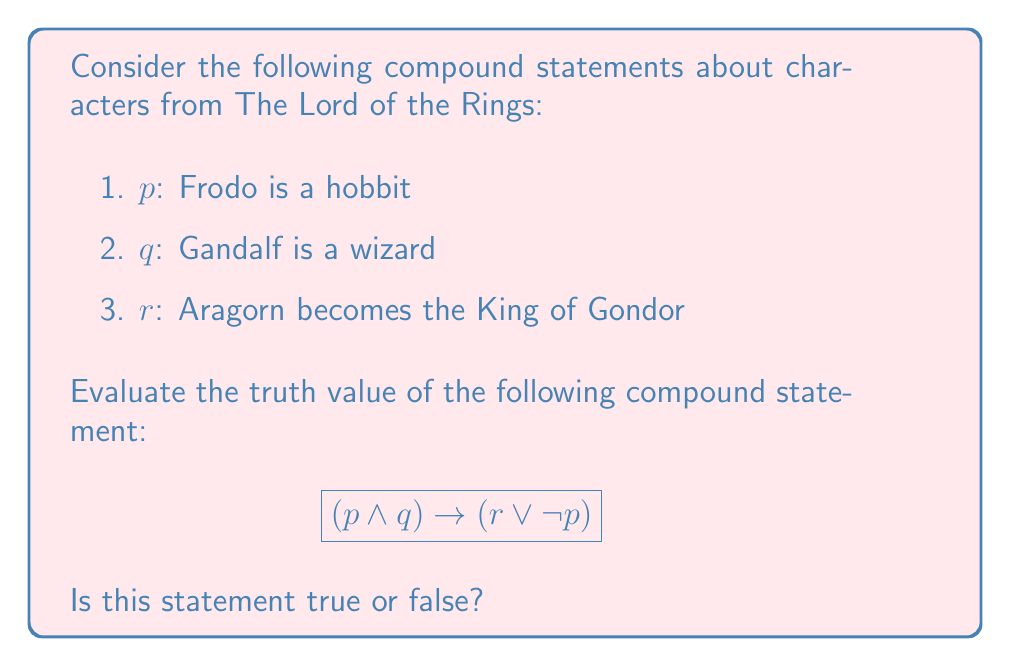What is the answer to this math problem? Let's evaluate this compound statement step-by-step:

1. First, we need to determine the truth values of the individual statements:
   $p$: True (Frodo is indeed a hobbit)
   $q$: True (Gandalf is indeed a wizard)
   $r$: True (Aragorn does become the King of Gondor)

2. Now, let's evaluate the left side of the implication: $(p \land q)$
   $p \land q$ = True $\land$ True = True

3. Next, let's evaluate the right side of the implication: $(r \lor \neg p)$
   $\neg p$ = False (since $p$ is True)
   $r \lor \neg p$ = True $\lor$ False = True

4. Now we have the implication: True $\rightarrow$ True

5. Recall the truth table for implication:
   $$\begin{array}{cc|c}
   p & q & p \rightarrow q \\
   \hline
   T & T & T \\
   T & F & F \\
   F & T & T \\
   F & F & T
   \end{array}$$

6. Since we have True $\rightarrow$ True, this corresponds to the first row of the truth table.

Therefore, the compound statement $(p \land q) \rightarrow (r \lor \neg p)$ is true.
Answer: True 